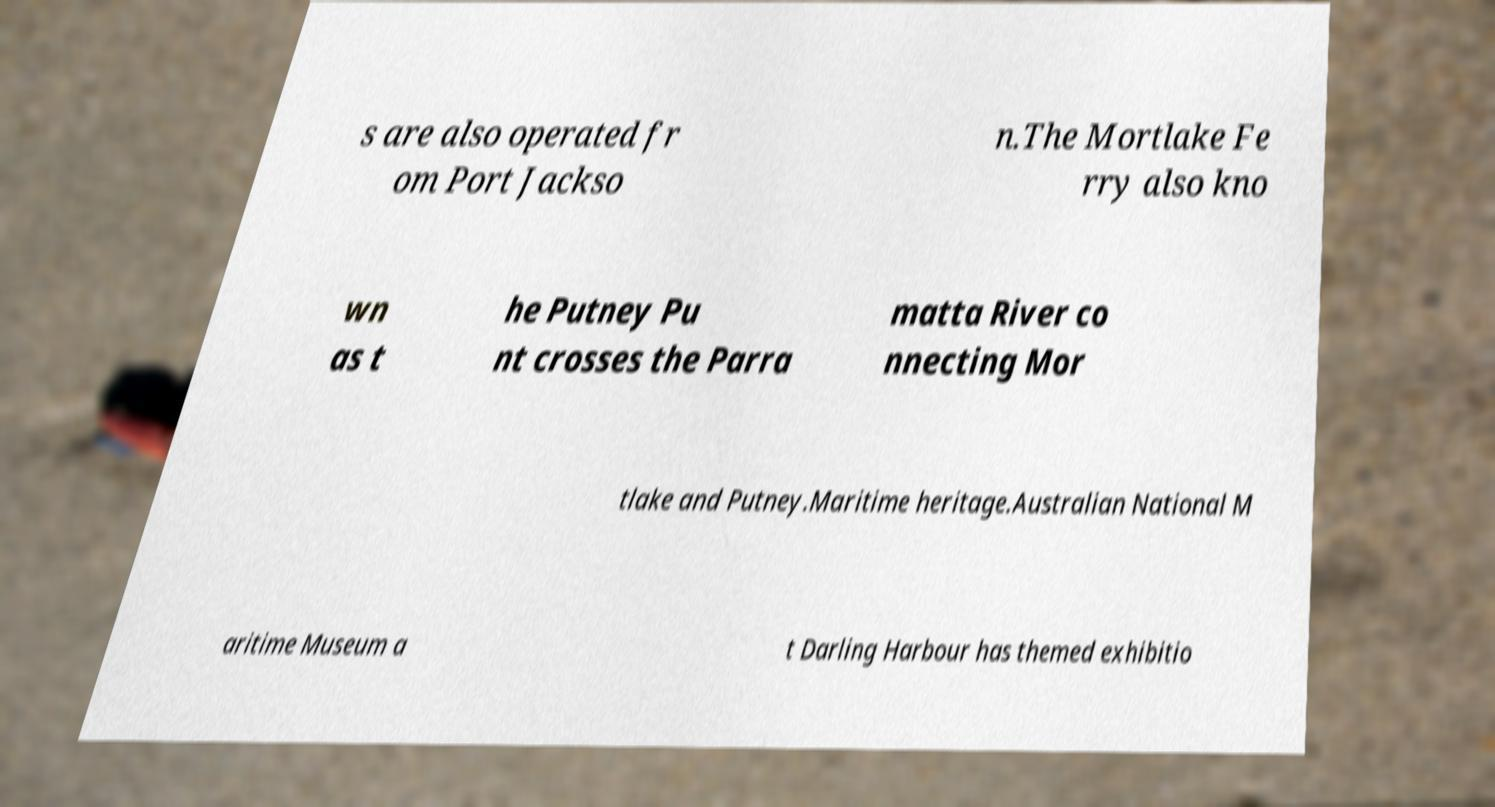Please read and relay the text visible in this image. What does it say? s are also operated fr om Port Jackso n.The Mortlake Fe rry also kno wn as t he Putney Pu nt crosses the Parra matta River co nnecting Mor tlake and Putney.Maritime heritage.Australian National M aritime Museum a t Darling Harbour has themed exhibitio 